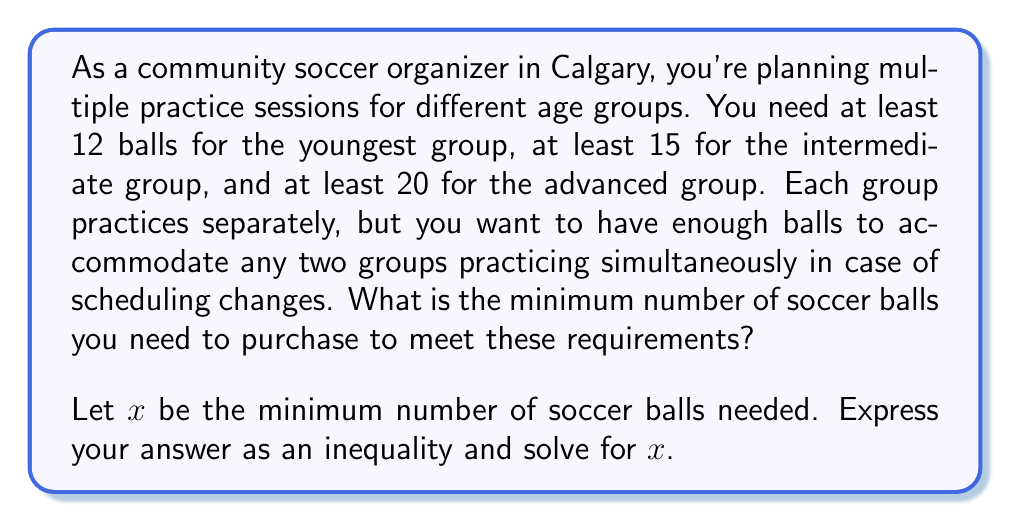Could you help me with this problem? To solve this problem, we need to consider the constraints and use inequalities to find the minimum number of balls needed.

1) First, let's consider the individual group requirements:
   Youngest group: $x \geq 12$
   Intermediate group: $x \geq 15$
   Advanced group: $x \geq 20$

2) Now, we need to consider the requirement for any two groups practicing simultaneously:
   Youngest + Intermediate: $x \geq 12 + 15 = 27$
   Youngest + Advanced: $x \geq 12 + 20 = 32$
   Intermediate + Advanced: $x \geq 15 + 20 = 35$

3) The minimum number of balls must satisfy all these conditions. Mathematically, this is expressed as:

   $$x \geq \max(12, 15, 20, 27, 32, 35)$$

4) The maximum value in this set is 35, so our inequality becomes:

   $$x \geq 35$$

5) Since we're looking for the minimum number of balls, and $x$ represents the number of balls (which must be a whole number), the smallest value of $x$ that satisfies this inequality is 35.

Therefore, the minimum number of soccer balls needed is 35.
Answer: $x \geq 35$, where $x = 35$ is the minimum number of soccer balls needed. 